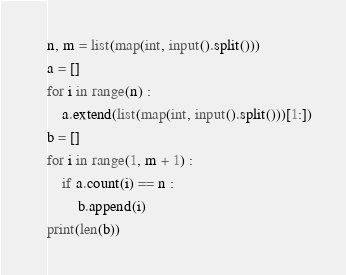Convert code to text. <code><loc_0><loc_0><loc_500><loc_500><_Python_>n, m = list(map(int, input().split()))
a = []
for i in range(n) :
    a.extend(list(map(int, input().split()))[1:])
b = []
for i in range(1, m + 1) :
    if a.count(i) == n :
        b.append(i)
print(len(b))
</code> 